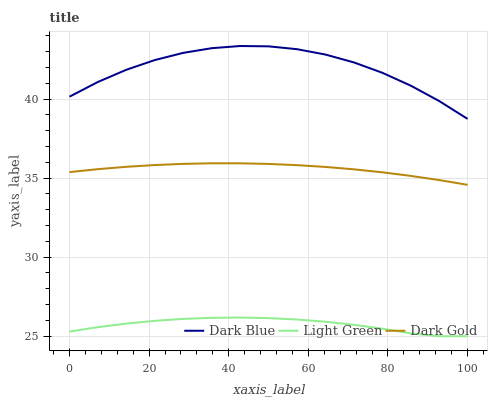Does Light Green have the minimum area under the curve?
Answer yes or no. Yes. Does Dark Blue have the maximum area under the curve?
Answer yes or no. Yes. Does Dark Gold have the minimum area under the curve?
Answer yes or no. No. Does Dark Gold have the maximum area under the curve?
Answer yes or no. No. Is Dark Gold the smoothest?
Answer yes or no. Yes. Is Dark Blue the roughest?
Answer yes or no. Yes. Is Light Green the smoothest?
Answer yes or no. No. Is Light Green the roughest?
Answer yes or no. No. Does Light Green have the lowest value?
Answer yes or no. Yes. Does Dark Gold have the lowest value?
Answer yes or no. No. Does Dark Blue have the highest value?
Answer yes or no. Yes. Does Dark Gold have the highest value?
Answer yes or no. No. Is Light Green less than Dark Gold?
Answer yes or no. Yes. Is Dark Blue greater than Dark Gold?
Answer yes or no. Yes. Does Light Green intersect Dark Gold?
Answer yes or no. No. 